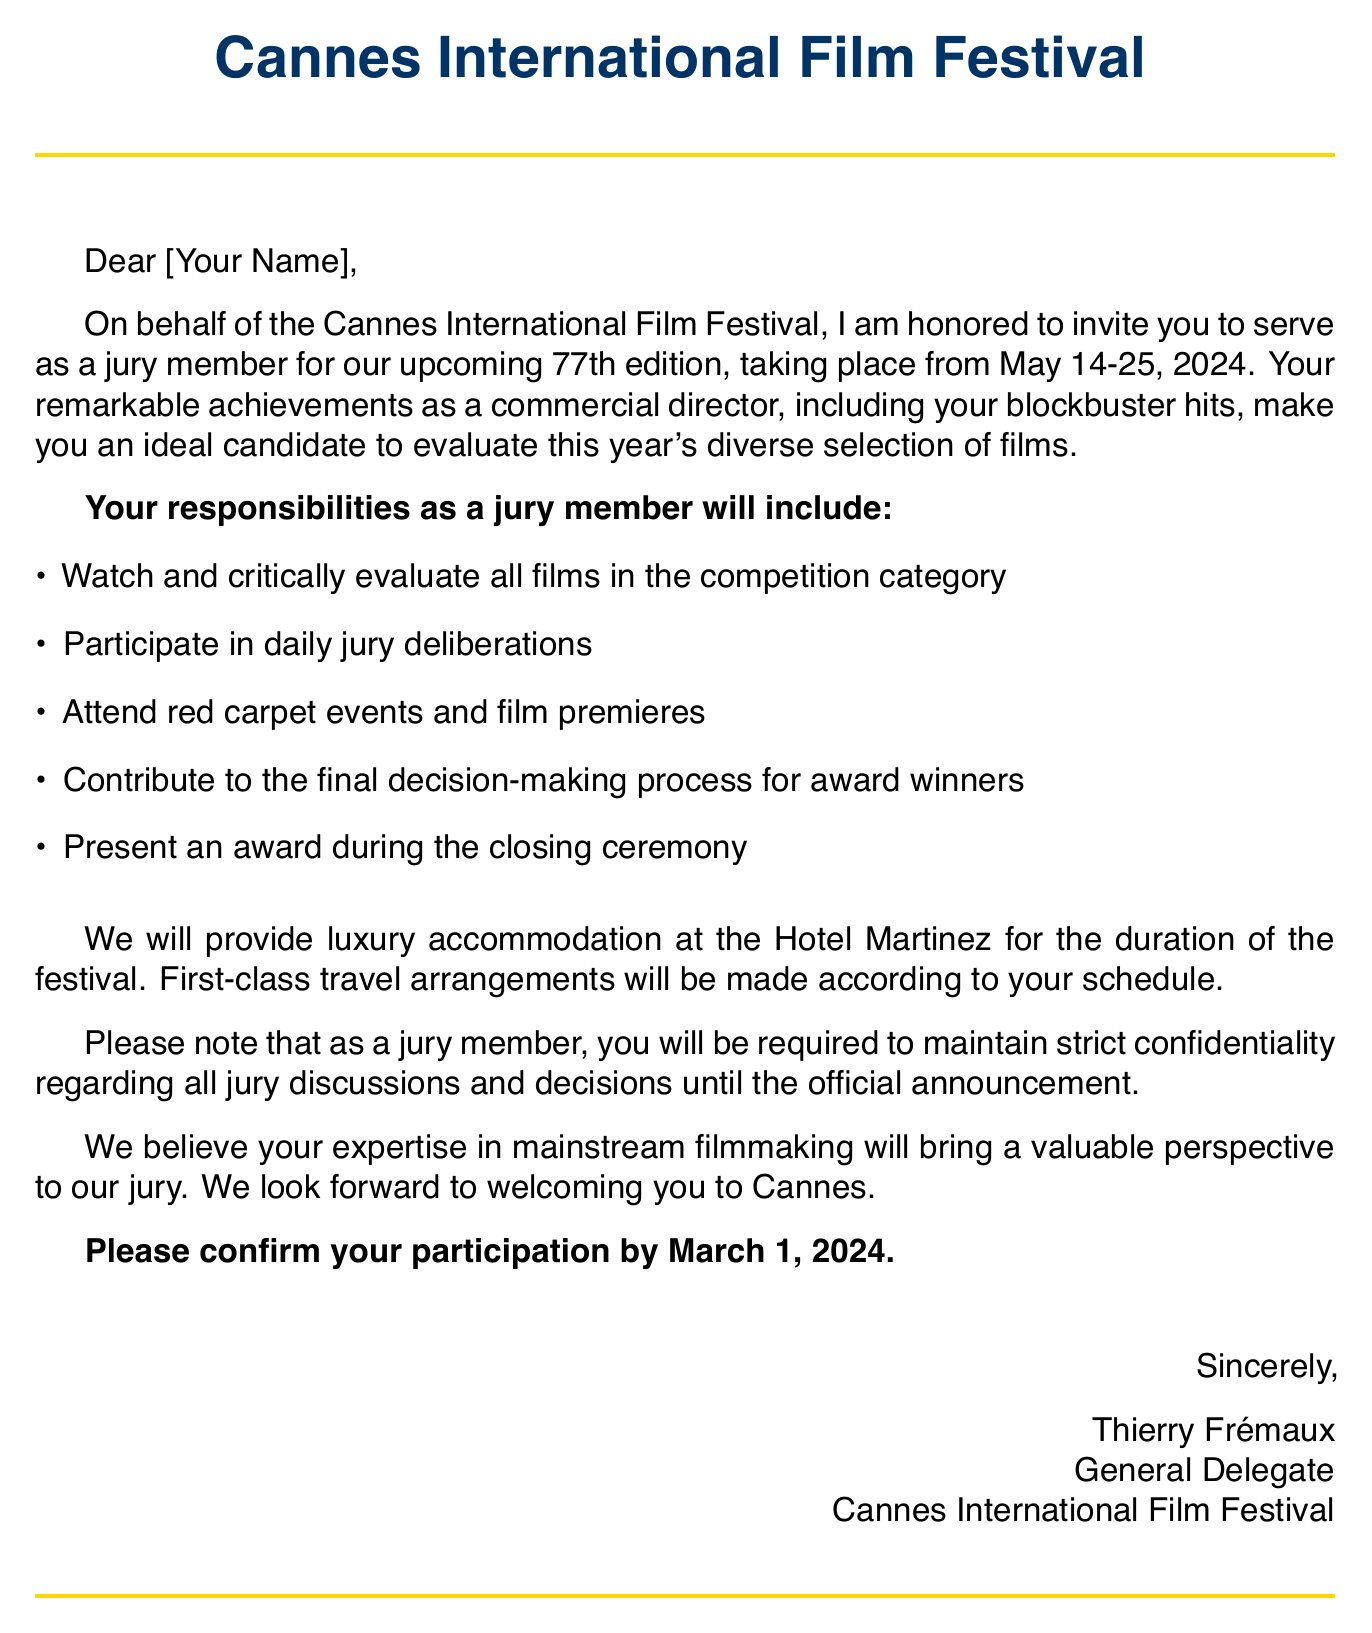What is the name of the film festival? The name of the film festival mentioned in the document is the Cannes International Film Festival.
Answer: Cannes International Film Festival What are the festival dates? The document specifies the dates of the festival, which are from May 14 to May 25, 2024.
Answer: May 14-25, 2024 What will be provided for accommodation? The document states that luxury accommodation will be provided at the Hotel Martinez.
Answer: Hotel Martinez What is one of the jury member responsibilities? One of the responsibilities listed in the document is to watch and critically evaluate all films in the competition category.
Answer: Watch and critically evaluate all films in the competition category When is the RSVP deadline? The invitation specifies that the RSVP deadline to confirm participation is March 1, 2024.
Answer: March 1, 2024 What is required regarding jury discussions? The document requires that jury members maintain strict confidentiality regarding all jury discussions.
Answer: Maintain strict confidentiality Who is the sender of the invitation? The sender of the invitation is identified as Thierry Frémaux, the General Delegate of the Cannes International Film Festival.
Answer: Thierry Frémaux What type of travel arrangements will be made? The document notes that first-class travel arrangements will be made according to the jury member's schedule.
Answer: First-class travel arrangements What edition of the festival is this? The invitation indicates that this is the 77th edition of the Cannes International Film Festival.
Answer: 77th edition What is the purpose of the invitation? The primary purpose of the invitation is to invite the recipient to serve as a jury member for the festival.
Answer: Serve as a jury member 